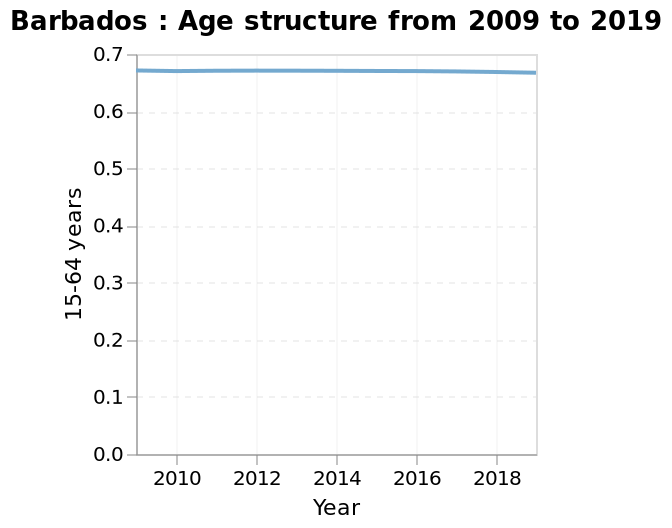<image>
What is the range of years represented on the x-axis of the line chart?  The range of years represented on the x-axis of the line chart is from 2010 to 2018. please describe the details of the chart Barbados : Age structure from 2009 to 2019 is a line chart. The y-axis plots 15-64 years with scale from 0.0 to 0.7 while the x-axis plots Year using linear scale from 2010 to 2018. When looking at the line graph, does it appear that the age structure has changed over time? At first glance, the line on the graph shows a practically horizontal trend, indicating that the age structure has remained relatively stable from 2010 to 2018. What is the value of the Y axis in 2018?  The value on the Y axis in 2018 is approximately 0.675. Is the range of years represented on the x-axis of the line chart from 2011 to 2017? No. The range of years represented on the x-axis of the line chart is from 2010 to 2018. 